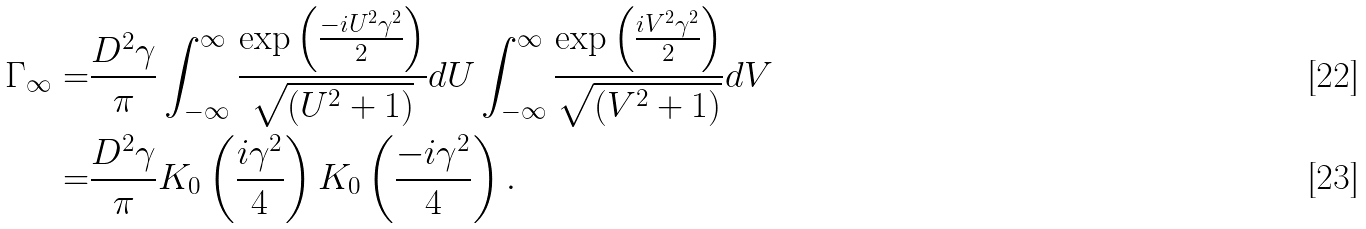<formula> <loc_0><loc_0><loc_500><loc_500>\Gamma _ { \infty } = & \frac { D ^ { 2 } \gamma } { \pi } \int _ { - \infty } ^ { \infty } \frac { \exp \left ( \frac { - i U ^ { 2 } \gamma ^ { 2 } } { 2 } \right ) } { \sqrt { \left ( U ^ { 2 } + 1 \right ) } } d U \int _ { - \infty } ^ { \infty } \frac { \exp \left ( \frac { i V ^ { 2 } \gamma ^ { 2 } } { 2 } \right ) } { \sqrt { \left ( V ^ { 2 } + 1 \right ) } } d V \\ = & \frac { D ^ { 2 } \gamma } { \pi } K _ { 0 } \left ( \frac { i \gamma ^ { 2 } } { 4 } \right ) K _ { 0 } \left ( \frac { - i \gamma ^ { 2 } } { 4 } \right ) .</formula> 